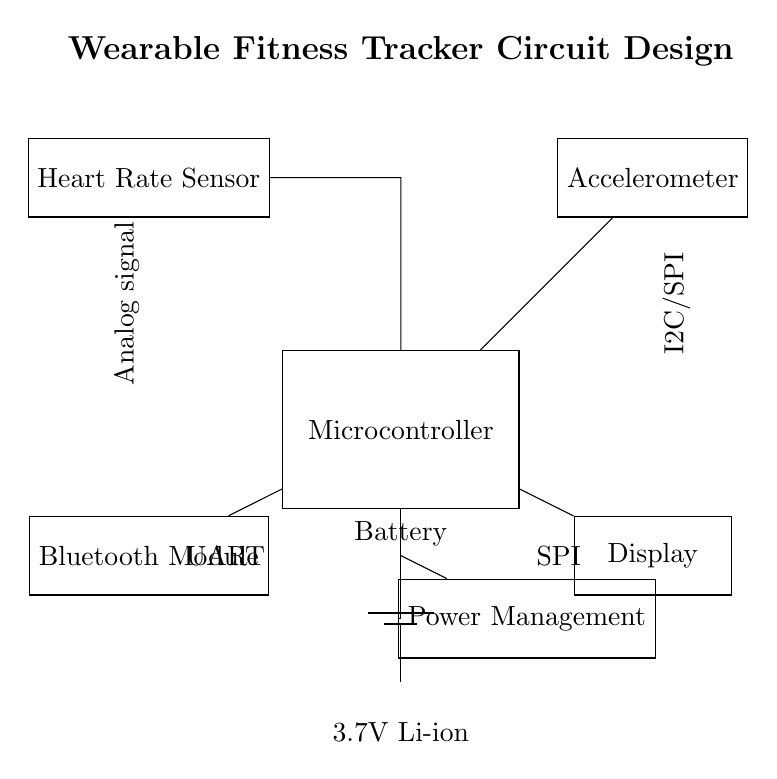What is the main component of the circuit? The main component is the Microcontroller, which coordinates between the sensor data inputs and outputs to the display and Bluetooth module.
Answer: Microcontroller How is the heart rate sensor connected? The heart rate sensor is connected by an analog signal line to the microcontroller, indicating that it sends direct analog signals related to heart rate for processing.
Answer: Analog signal What type of data does the accelerometer use? The accelerometer communicates with the microcontroller using either I2C or SPI protocols, which are digital communication methods suitable for transmitting sensor data.
Answer: I2C/SPI What is the power source for this circuit? The circuit is powered by a 3.7V Lithium-ion battery, ensuring that all components function within their required voltage range for operation.
Answer: 3.7V Li-ion Which component manages the power supply? The Power Management Unit (PMU) is responsible for regulating the power supply from the battery to various components of the circuit, ensuring voltage levels are appropriate.
Answer: Power Management How does the microcontroller communicate with the Bluetooth module? The microcontroller communicates with the Bluetooth module using UART, which is a serial communication protocol suitable for connecting to wireless modules.
Answer: UART What is the purpose of the display in this circuit? The display serves to present real-time data to the user, such as heart rate and movement statistics, allowing athletes to monitor their performance during training.
Answer: Display 